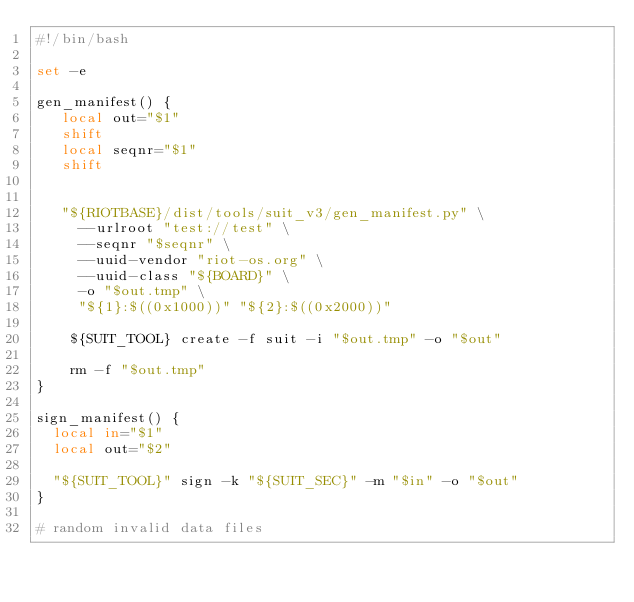Convert code to text. <code><loc_0><loc_0><loc_500><loc_500><_Bash_>#!/bin/bash

set -e

gen_manifest() {
   local out="$1"
   shift
   local seqnr="$1"
   shift


   "${RIOTBASE}/dist/tools/suit_v3/gen_manifest.py" \
     --urlroot "test://test" \
     --seqnr "$seqnr" \
     --uuid-vendor "riot-os.org" \
     --uuid-class "${BOARD}" \
     -o "$out.tmp" \
     "${1}:$((0x1000))" "${2}:$((0x2000))"

    ${SUIT_TOOL} create -f suit -i "$out.tmp" -o "$out"

    rm -f "$out.tmp"
}

sign_manifest() {
  local in="$1"
  local out="$2"

  "${SUIT_TOOL}" sign -k "${SUIT_SEC}" -m "$in" -o "$out"
}

# random invalid data files</code> 